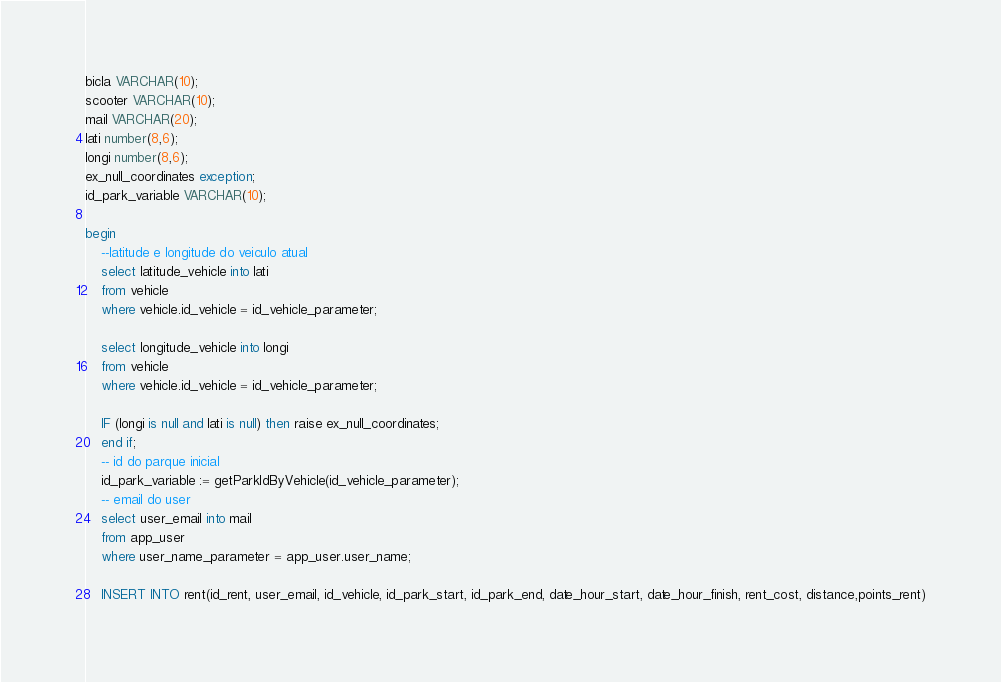Convert code to text. <code><loc_0><loc_0><loc_500><loc_500><_SQL_>
bicla VARCHAR(10);
scooter VARCHAR(10);
mail VARCHAR(20);
lati number(8,6);
longi number(8,6);
ex_null_coordinates exception;
id_park_variable VARCHAR(10);

begin
	--latitude e longitude do veiculo atual
    select latitude_vehicle into lati
    from vehicle
    where vehicle.id_vehicle = id_vehicle_parameter;

    select longitude_vehicle into longi
    from vehicle
    where vehicle.id_vehicle = id_vehicle_parameter;

    IF (longi is null and lati is null) then raise ex_null_coordinates;
    end if;
    -- id do parque inicial
    id_park_variable := getParkIdByVehicle(id_vehicle_parameter);
    -- email do user
    select user_email into mail
    from app_user 
    where user_name_parameter = app_user.user_name;

    INSERT INTO rent(id_rent, user_email, id_vehicle, id_park_start, id_park_end, date_hour_start, date_hour_finish, rent_cost, distance,points_rent)</code> 